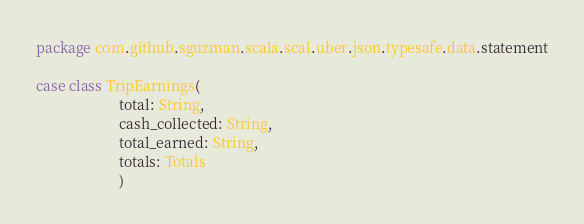<code> <loc_0><loc_0><loc_500><loc_500><_Scala_>package com.github.sguzman.scala.scal.uber.json.typesafe.data.statement

case class TripEarnings(
                       total: String,
                       cash_collected: String,
                       total_earned: String,
                       totals: Totals
                       )
</code> 